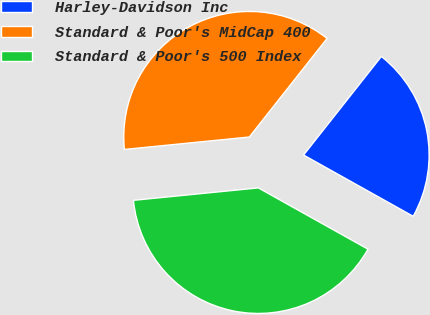Convert chart. <chart><loc_0><loc_0><loc_500><loc_500><pie_chart><fcel>Harley-Davidson Inc<fcel>Standard & Poor's MidCap 400<fcel>Standard & Poor's 500 Index<nl><fcel>22.48%<fcel>37.21%<fcel>40.31%<nl></chart> 